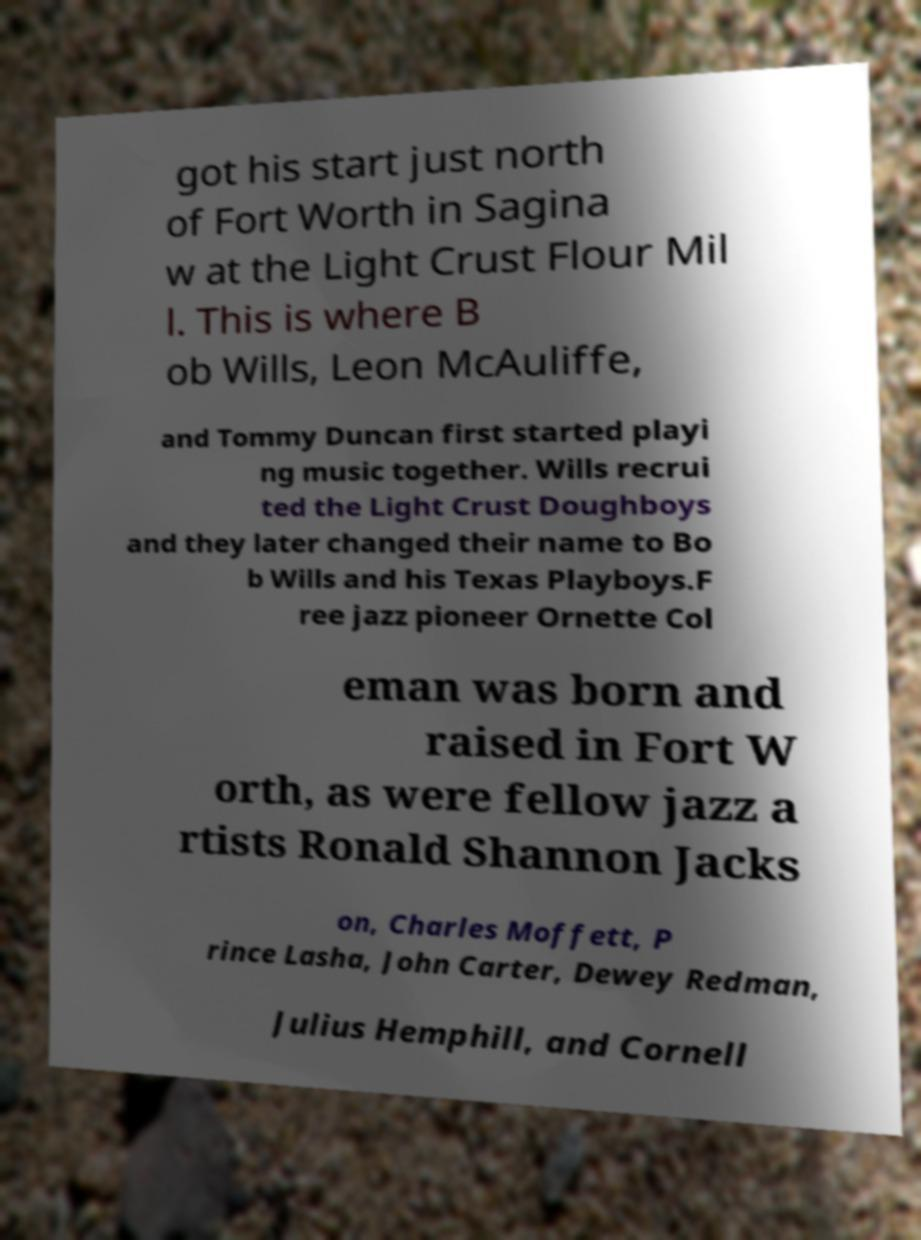Can you accurately transcribe the text from the provided image for me? got his start just north of Fort Worth in Sagina w at the Light Crust Flour Mil l. This is where B ob Wills, Leon McAuliffe, and Tommy Duncan first started playi ng music together. Wills recrui ted the Light Crust Doughboys and they later changed their name to Bo b Wills and his Texas Playboys.F ree jazz pioneer Ornette Col eman was born and raised in Fort W orth, as were fellow jazz a rtists Ronald Shannon Jacks on, Charles Moffett, P rince Lasha, John Carter, Dewey Redman, Julius Hemphill, and Cornell 